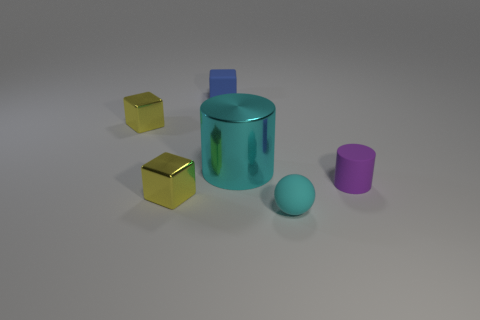How many yellow objects are small cubes or rubber blocks?
Offer a very short reply. 2. Are there any yellow shiny blocks that have the same size as the purple cylinder?
Your response must be concise. Yes. There is a cyan matte sphere to the right of the large object; is its size the same as the cyan shiny cylinder behind the matte cylinder?
Your response must be concise. No. How many objects are big brown spheres or tiny cubes that are in front of the large cyan metal cylinder?
Ensure brevity in your answer.  1. Is there a purple rubber object of the same shape as the big cyan thing?
Provide a short and direct response. Yes. There is a cyan object that is in front of the small yellow shiny block that is in front of the cyan metallic thing; what is its size?
Offer a very short reply. Small. Does the sphere have the same color as the big thing?
Your answer should be compact. Yes. What number of metallic objects are tiny things or small yellow objects?
Your answer should be very brief. 2. How many yellow blocks are there?
Ensure brevity in your answer.  2. Are the yellow thing that is in front of the small cylinder and the cylinder that is on the left side of the cyan rubber thing made of the same material?
Your answer should be very brief. Yes. 